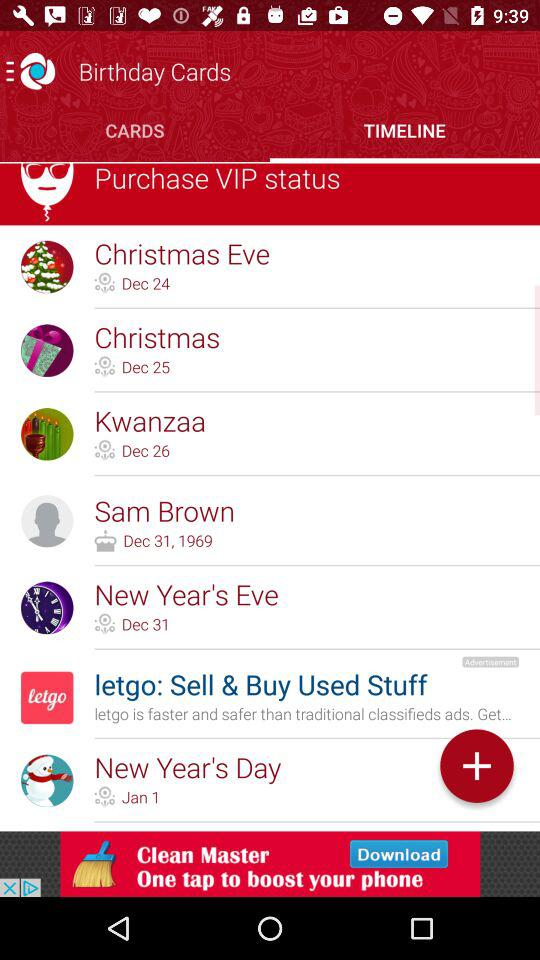What is the date of birth? The date of birth is 31st December, 1969. 